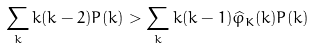<formula> <loc_0><loc_0><loc_500><loc_500>\sum _ { k } k ( k - 2 ) P ( k ) > \sum _ { k } k ( k - 1 ) \widehat { \varphi } _ { K } ( k ) P ( k )</formula> 